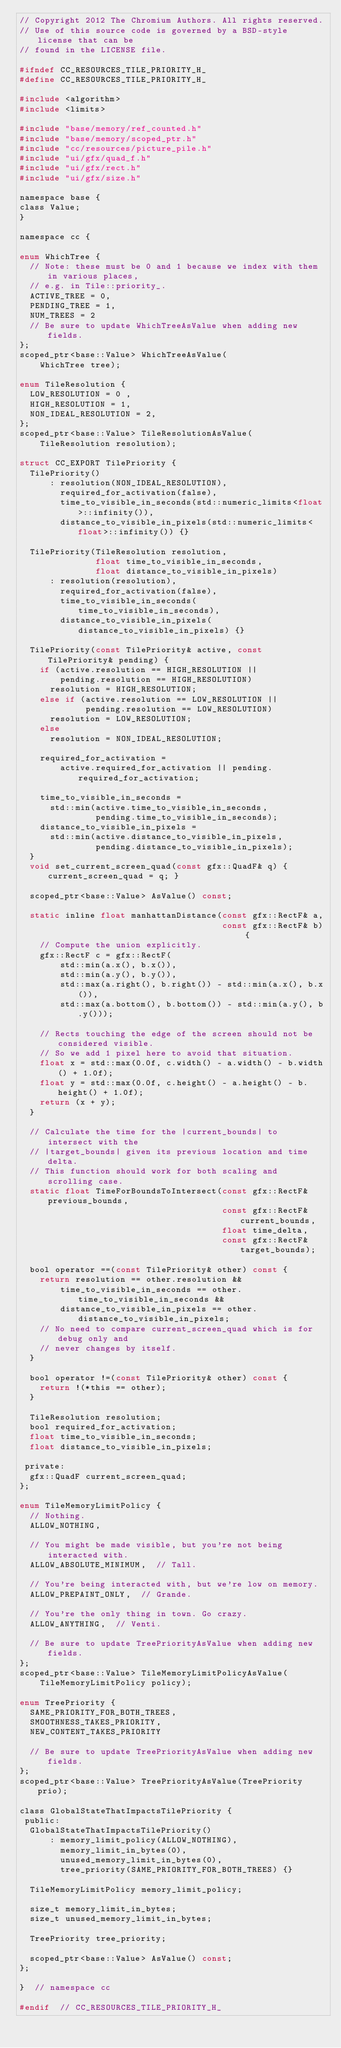<code> <loc_0><loc_0><loc_500><loc_500><_C_>// Copyright 2012 The Chromium Authors. All rights reserved.
// Use of this source code is governed by a BSD-style license that can be
// found in the LICENSE file.

#ifndef CC_RESOURCES_TILE_PRIORITY_H_
#define CC_RESOURCES_TILE_PRIORITY_H_

#include <algorithm>
#include <limits>

#include "base/memory/ref_counted.h"
#include "base/memory/scoped_ptr.h"
#include "cc/resources/picture_pile.h"
#include "ui/gfx/quad_f.h"
#include "ui/gfx/rect.h"
#include "ui/gfx/size.h"

namespace base {
class Value;
}

namespace cc {

enum WhichTree {
  // Note: these must be 0 and 1 because we index with them in various places,
  // e.g. in Tile::priority_.
  ACTIVE_TREE = 0,
  PENDING_TREE = 1,
  NUM_TREES = 2
  // Be sure to update WhichTreeAsValue when adding new fields.
};
scoped_ptr<base::Value> WhichTreeAsValue(
    WhichTree tree);

enum TileResolution {
  LOW_RESOLUTION = 0 ,
  HIGH_RESOLUTION = 1,
  NON_IDEAL_RESOLUTION = 2,
};
scoped_ptr<base::Value> TileResolutionAsValue(
    TileResolution resolution);

struct CC_EXPORT TilePriority {
  TilePriority()
      : resolution(NON_IDEAL_RESOLUTION),
        required_for_activation(false),
        time_to_visible_in_seconds(std::numeric_limits<float>::infinity()),
        distance_to_visible_in_pixels(std::numeric_limits<float>::infinity()) {}

  TilePriority(TileResolution resolution,
               float time_to_visible_in_seconds,
               float distance_to_visible_in_pixels)
      : resolution(resolution),
        required_for_activation(false),
        time_to_visible_in_seconds(time_to_visible_in_seconds),
        distance_to_visible_in_pixels(distance_to_visible_in_pixels) {}

  TilePriority(const TilePriority& active, const TilePriority& pending) {
    if (active.resolution == HIGH_RESOLUTION ||
        pending.resolution == HIGH_RESOLUTION)
      resolution = HIGH_RESOLUTION;
    else if (active.resolution == LOW_RESOLUTION ||
             pending.resolution == LOW_RESOLUTION)
      resolution = LOW_RESOLUTION;
    else
      resolution = NON_IDEAL_RESOLUTION;

    required_for_activation =
        active.required_for_activation || pending.required_for_activation;

    time_to_visible_in_seconds =
      std::min(active.time_to_visible_in_seconds,
               pending.time_to_visible_in_seconds);
    distance_to_visible_in_pixels =
      std::min(active.distance_to_visible_in_pixels,
               pending.distance_to_visible_in_pixels);
  }
  void set_current_screen_quad(const gfx::QuadF& q) { current_screen_quad = q; }

  scoped_ptr<base::Value> AsValue() const;

  static inline float manhattanDistance(const gfx::RectF& a,
                                        const gfx::RectF& b) {
    // Compute the union explicitly.
    gfx::RectF c = gfx::RectF(
        std::min(a.x(), b.x()),
        std::min(a.y(), b.y()),
        std::max(a.right(), b.right()) - std::min(a.x(), b.x()),
        std::max(a.bottom(), b.bottom()) - std::min(a.y(), b.y()));

    // Rects touching the edge of the screen should not be considered visible.
    // So we add 1 pixel here to avoid that situation.
    float x = std::max(0.0f, c.width() - a.width() - b.width() + 1.0f);
    float y = std::max(0.0f, c.height() - a.height() - b.height() + 1.0f);
    return (x + y);
  }

  // Calculate the time for the |current_bounds| to intersect with the
  // |target_bounds| given its previous location and time delta.
  // This function should work for both scaling and scrolling case.
  static float TimeForBoundsToIntersect(const gfx::RectF& previous_bounds,
                                        const gfx::RectF& current_bounds,
                                        float time_delta,
                                        const gfx::RectF& target_bounds);

  bool operator ==(const TilePriority& other) const {
    return resolution == other.resolution &&
        time_to_visible_in_seconds == other.time_to_visible_in_seconds &&
        distance_to_visible_in_pixels == other.distance_to_visible_in_pixels;
    // No need to compare current_screen_quad which is for debug only and
    // never changes by itself.
  }

  bool operator !=(const TilePriority& other) const {
    return !(*this == other);
  }

  TileResolution resolution;
  bool required_for_activation;
  float time_to_visible_in_seconds;
  float distance_to_visible_in_pixels;

 private:
  gfx::QuadF current_screen_quad;
};

enum TileMemoryLimitPolicy {
  // Nothing.
  ALLOW_NOTHING,

  // You might be made visible, but you're not being interacted with.
  ALLOW_ABSOLUTE_MINIMUM,  // Tall.

  // You're being interacted with, but we're low on memory.
  ALLOW_PREPAINT_ONLY,  // Grande.

  // You're the only thing in town. Go crazy.
  ALLOW_ANYTHING,  // Venti.

  // Be sure to update TreePriorityAsValue when adding new fields.
};
scoped_ptr<base::Value> TileMemoryLimitPolicyAsValue(
    TileMemoryLimitPolicy policy);

enum TreePriority {
  SAME_PRIORITY_FOR_BOTH_TREES,
  SMOOTHNESS_TAKES_PRIORITY,
  NEW_CONTENT_TAKES_PRIORITY

  // Be sure to update TreePriorityAsValue when adding new fields.
};
scoped_ptr<base::Value> TreePriorityAsValue(TreePriority prio);

class GlobalStateThatImpactsTilePriority {
 public:
  GlobalStateThatImpactsTilePriority()
      : memory_limit_policy(ALLOW_NOTHING),
        memory_limit_in_bytes(0),
        unused_memory_limit_in_bytes(0),
        tree_priority(SAME_PRIORITY_FOR_BOTH_TREES) {}

  TileMemoryLimitPolicy memory_limit_policy;

  size_t memory_limit_in_bytes;
  size_t unused_memory_limit_in_bytes;

  TreePriority tree_priority;

  scoped_ptr<base::Value> AsValue() const;
};

}  // namespace cc

#endif  // CC_RESOURCES_TILE_PRIORITY_H_
</code> 